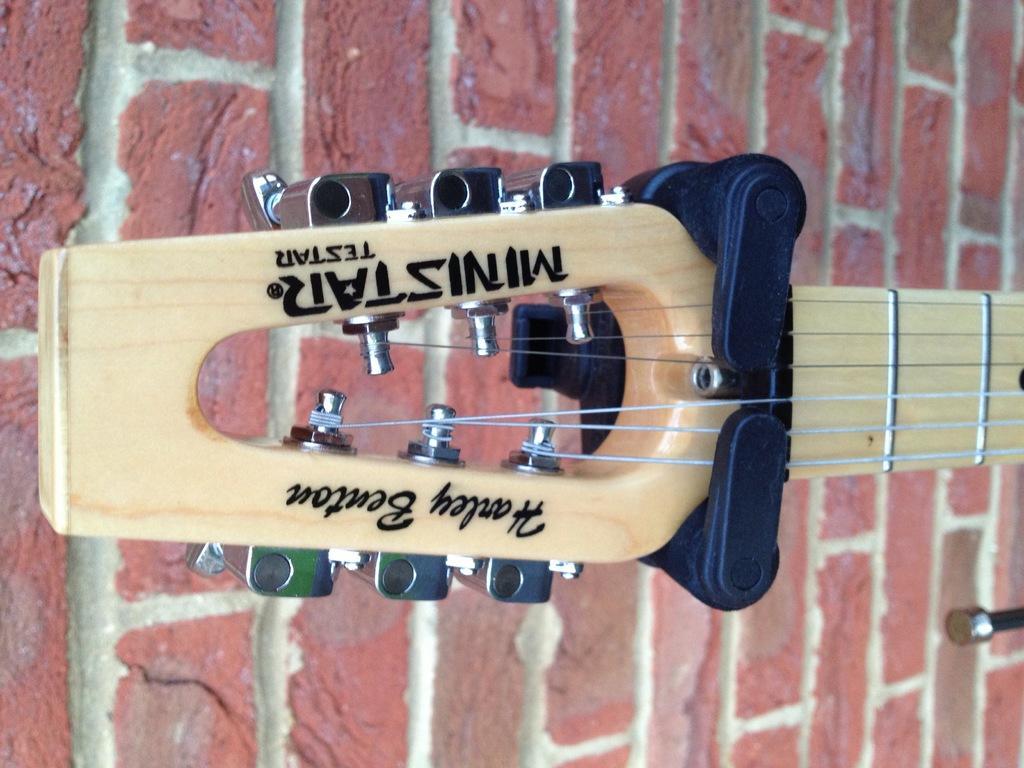Can you describe this image briefly? In this image i can see a guitar at the background i can see a wall. 